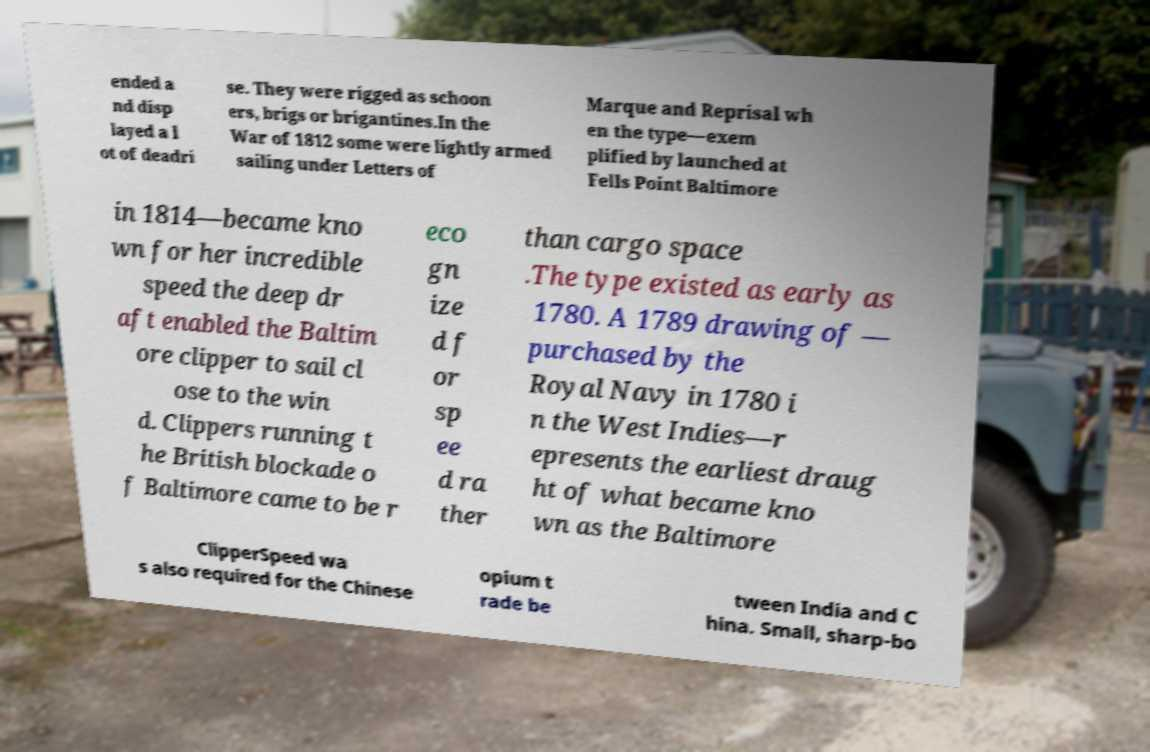Can you read and provide the text displayed in the image?This photo seems to have some interesting text. Can you extract and type it out for me? ended a nd disp layed a l ot of deadri se. They were rigged as schoon ers, brigs or brigantines.In the War of 1812 some were lightly armed sailing under Letters of Marque and Reprisal wh en the type—exem plified by launched at Fells Point Baltimore in 1814—became kno wn for her incredible speed the deep dr aft enabled the Baltim ore clipper to sail cl ose to the win d. Clippers running t he British blockade o f Baltimore came to be r eco gn ize d f or sp ee d ra ther than cargo space .The type existed as early as 1780. A 1789 drawing of — purchased by the Royal Navy in 1780 i n the West Indies—r epresents the earliest draug ht of what became kno wn as the Baltimore ClipperSpeed wa s also required for the Chinese opium t rade be tween India and C hina. Small, sharp-bo 